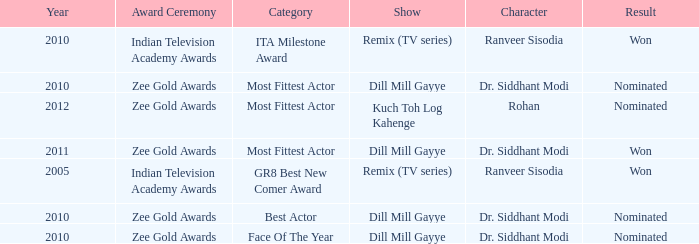Can you give me this table as a dict? {'header': ['Year', 'Award Ceremony', 'Category', 'Show', 'Character', 'Result'], 'rows': [['2010', 'Indian Television Academy Awards', 'ITA Milestone Award', 'Remix (TV series)', 'Ranveer Sisodia', 'Won'], ['2010', 'Zee Gold Awards', 'Most Fittest Actor', 'Dill Mill Gayye', 'Dr. Siddhant Modi', 'Nominated'], ['2012', 'Zee Gold Awards', 'Most Fittest Actor', 'Kuch Toh Log Kahenge', 'Rohan', 'Nominated'], ['2011', 'Zee Gold Awards', 'Most Fittest Actor', 'Dill Mill Gayye', 'Dr. Siddhant Modi', 'Won'], ['2005', 'Indian Television Academy Awards', 'GR8 Best New Comer Award', 'Remix (TV series)', 'Ranveer Sisodia', 'Won'], ['2010', 'Zee Gold Awards', 'Best Actor', 'Dill Mill Gayye', 'Dr. Siddhant Modi', 'Nominated'], ['2010', 'Zee Gold Awards', 'Face Of The Year', 'Dill Mill Gayye', 'Dr. Siddhant Modi', 'Nominated']]} Which show was nominated for the ITA Milestone Award at the Indian Television Academy Awards? Remix (TV series). 